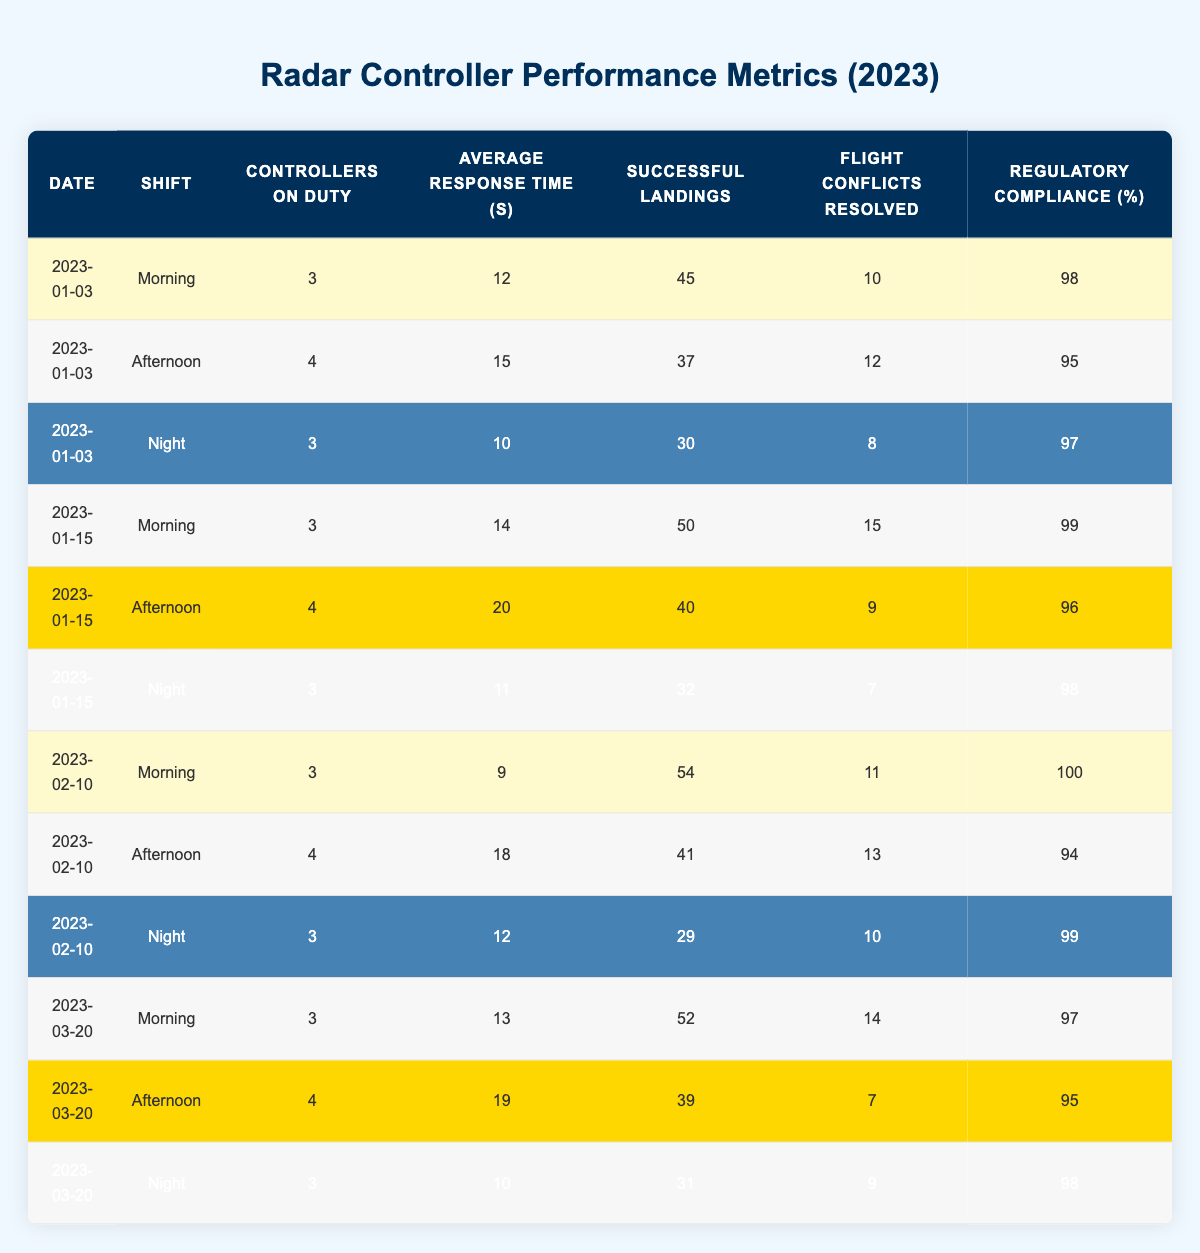What is the average regulatory compliance percentage for the evening shifts? To find the average regulatory compliance percentage for night shifts, we first isolate the rows for night shifts: on 2023-01-03 it is 97%, on 2023-01-15 it is 98%, on 2023-02-10 it is 99%, and on 2023-03-20 it is 98%. We sum these values: 97 + 98 + 99 + 98 = 392. Then, we divide by the number of entries (4): 392 / 4 = 98.
Answer: 98 How many successful landings were recorded on the morning shift on February 10, 2023? Referring to the table, on February 10, 2023, during the morning shift, there were 54 successful landings recorded.
Answer: 54 What was the average response time in seconds across all shifts on January 15, 2023? On January 15, 2023, the average response times for each shift are: Morning 14 seconds, Afternoon 20 seconds, and Night 11 seconds. We sum these for a total of 14 + 20 + 11 = 45 seconds and divide by the number of shifts (3). Thus, the average response time is 45 / 3 = 15.
Answer: 15 Did the number of successful landings increase or decrease from January 3 to January 15 during the morning shift? For the morning shift on January 3, there were 45 successful landings, while on January 15, there were 50 successful landings. Since 50 is greater than 45, we conclude that the number of successful landings increased.
Answer: Yes What is the maximum number of flight conflicts resolved in a single shift, and on which date and shift did this occur? Reviewing the table, the maximum number of flight conflicts resolved is 15, occurring during the morning shift on January 15, 2023.
Answer: 15 on January 15, Morning How did the number of controllers on duty compare between morning and afternoon shifts over the entire data set? By observing the table, the number of controllers on duty for morning shifts ranges from 3 to 3, while the afternoon shifts range from 4 to 4. This shows that afternoon shifts always had one more controller on duty than the morning shifts.
Answer: Afternoon shifts had more controllers What was the total successful landings across all shifts for the month of January? On January 3, there were 45 (Morning) + 37 (Afternoon) + 30 (Night) = 112 successful landings. On January 15, there were 50 (Morning) + 40 (Afternoon) + 32 (Night) = 122 successful landings. The total for January is 112 + 122 = 234 successful landings.
Answer: 234 Were the average response times higher in the afternoon rather than in the morning shifts based on the available data? Analyzing the average response times, the morning shifts have the following averages: 12 (Jan 3) + 14 (Jan 15) + 9 (Feb 10) + 13 (Mar 20), totaling 48 seconds for 4 entries, gives an average of 48/4 = 12 seconds. The afternoon shifts have 15 (Jan 3) + 20 (Jan 15) + 18 (Feb 10) + 19 (Mar 20), totaling 72 seconds for 4 entries, averaging 72/4 = 18 seconds. Thus, afternoon shifts have higher average response times.
Answer: Yes 